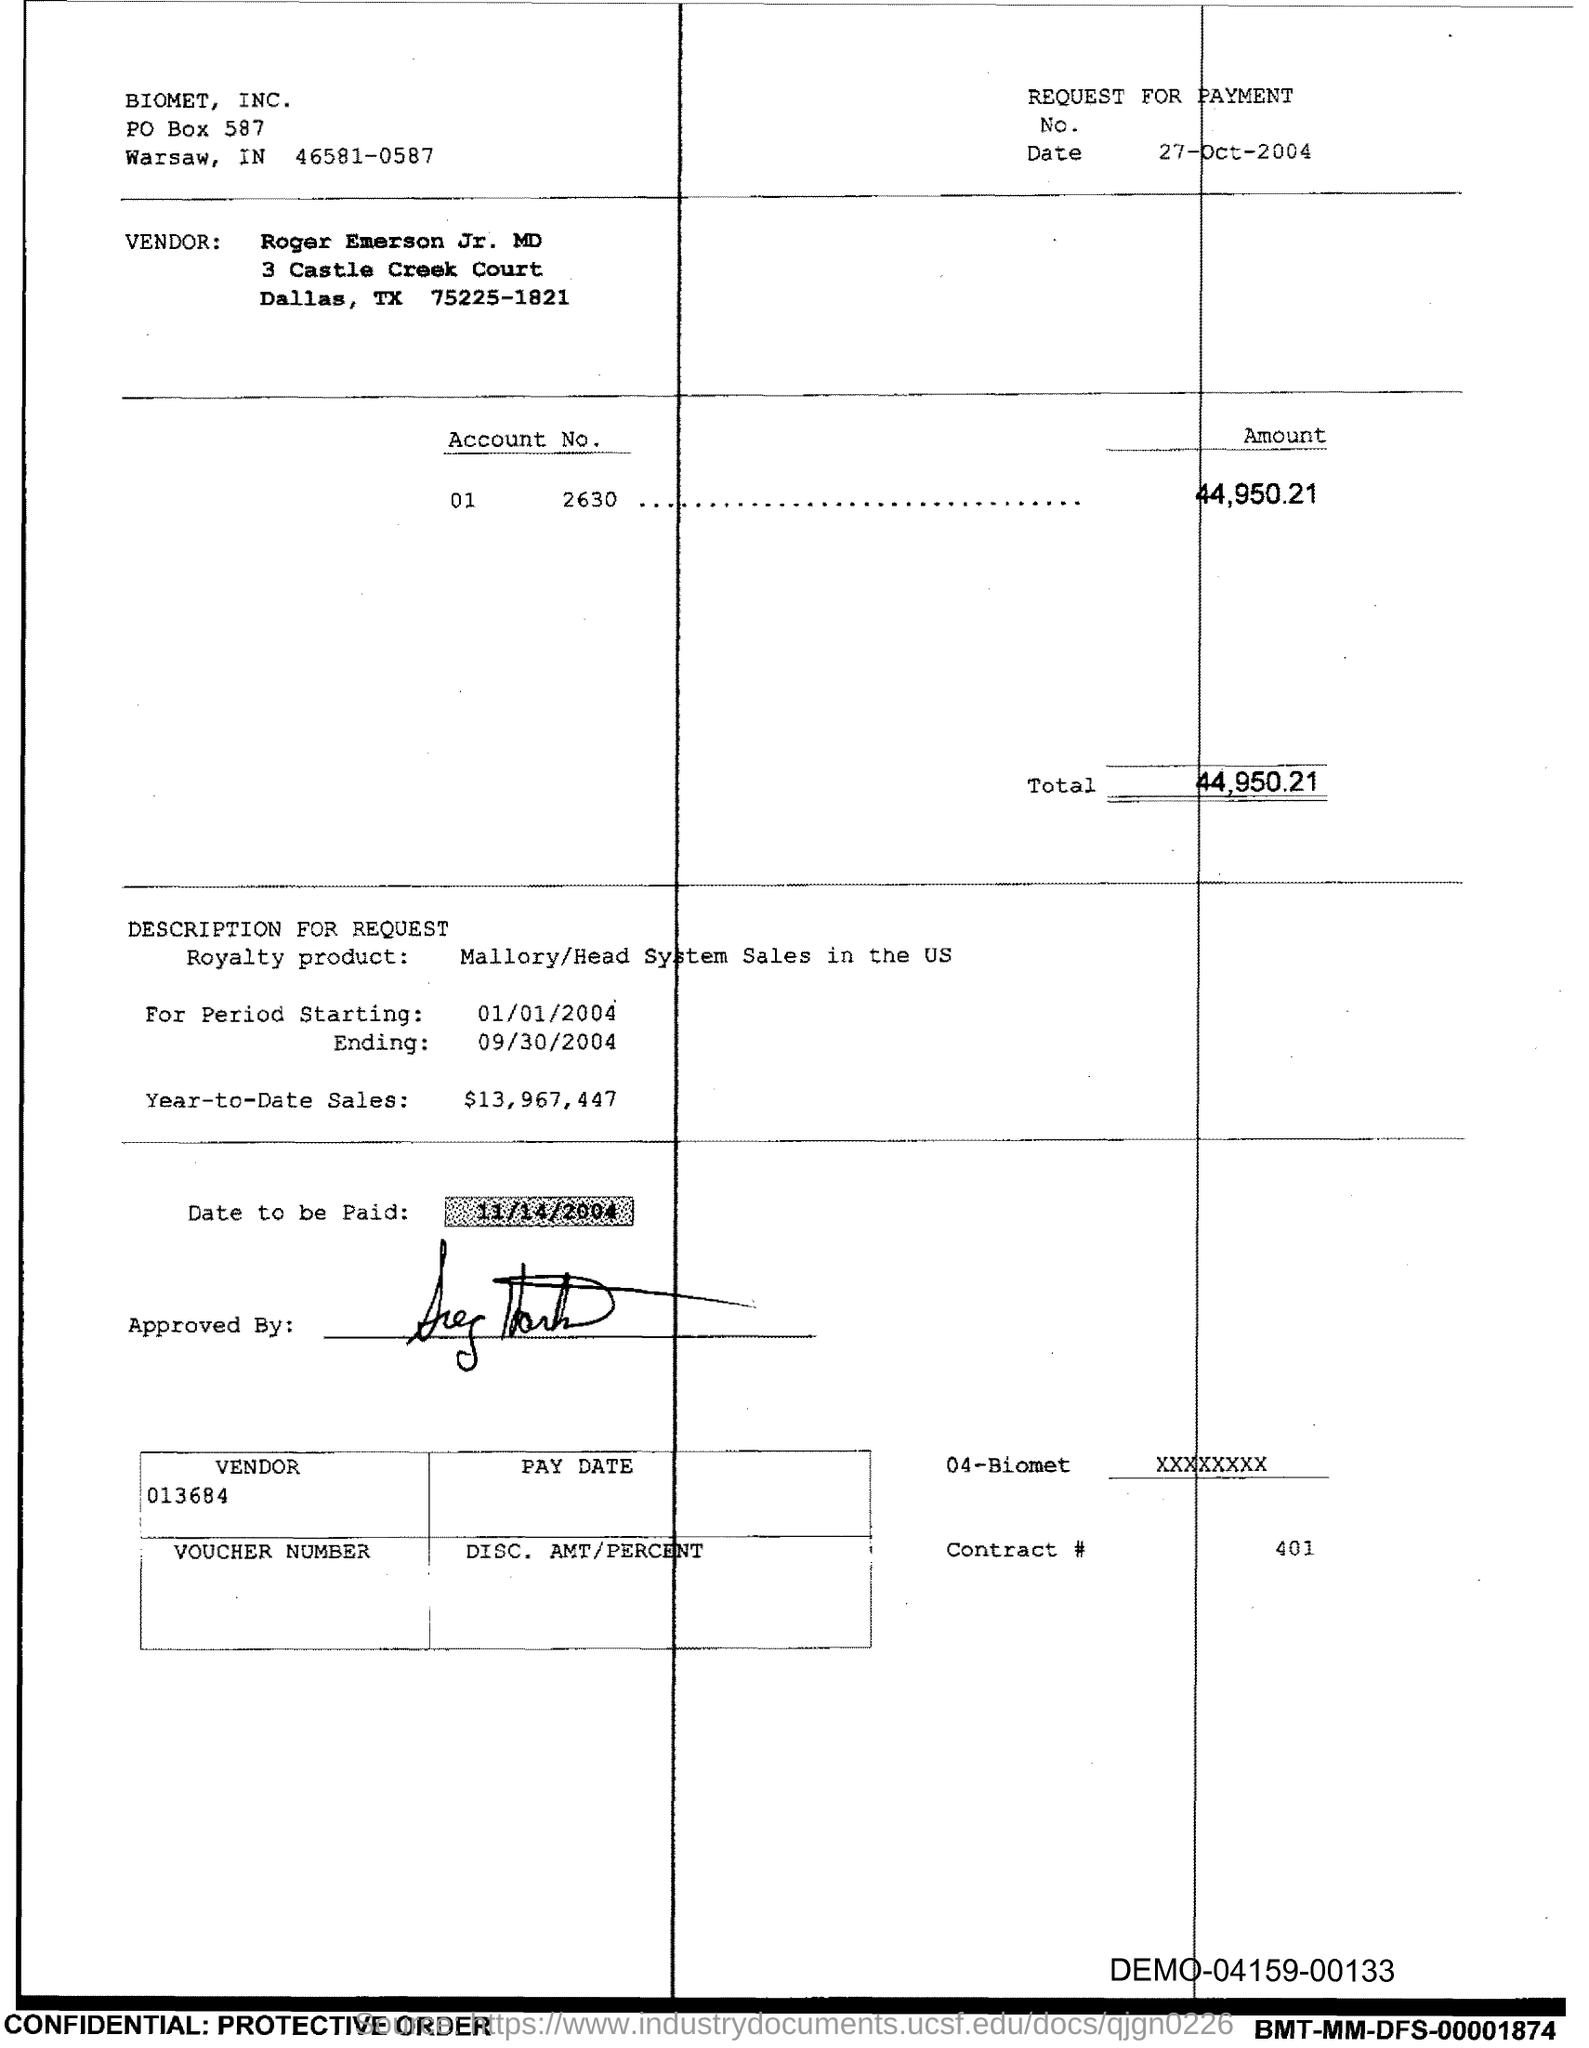What is the Total?
Your answer should be very brief. 44,950.21. What is the Contract # Number?
Give a very brief answer. 401. 